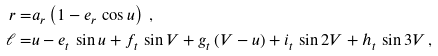Convert formula to latex. <formula><loc_0><loc_0><loc_500><loc_500>r = & a _ { r } \left ( 1 - e _ { r } \, \cos u \right ) \, , \\ \ell = & u - e _ { t } \, \sin u + f _ { t } \, \sin V + g _ { t } \, ( V - u ) + i _ { t } \, \sin 2 V + h _ { t } \, \sin 3 V \, ,</formula> 